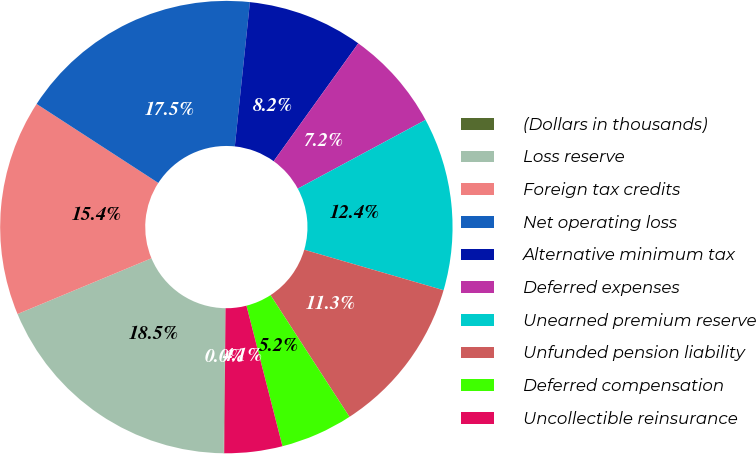Convert chart. <chart><loc_0><loc_0><loc_500><loc_500><pie_chart><fcel>(Dollars in thousands)<fcel>Loss reserve<fcel>Foreign tax credits<fcel>Net operating loss<fcel>Alternative minimum tax<fcel>Deferred expenses<fcel>Unearned premium reserve<fcel>Unfunded pension liability<fcel>Deferred compensation<fcel>Uncollectible reinsurance<nl><fcel>0.04%<fcel>18.53%<fcel>15.44%<fcel>17.5%<fcel>8.25%<fcel>7.23%<fcel>12.36%<fcel>11.34%<fcel>5.17%<fcel>4.14%<nl></chart> 